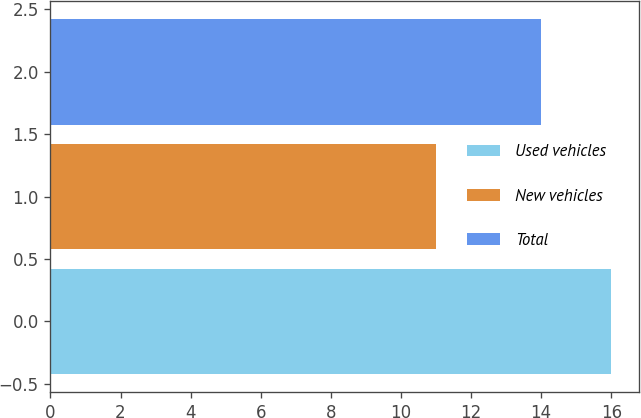Convert chart. <chart><loc_0><loc_0><loc_500><loc_500><bar_chart><fcel>Used vehicles<fcel>New vehicles<fcel>Total<nl><fcel>16<fcel>11<fcel>14<nl></chart> 